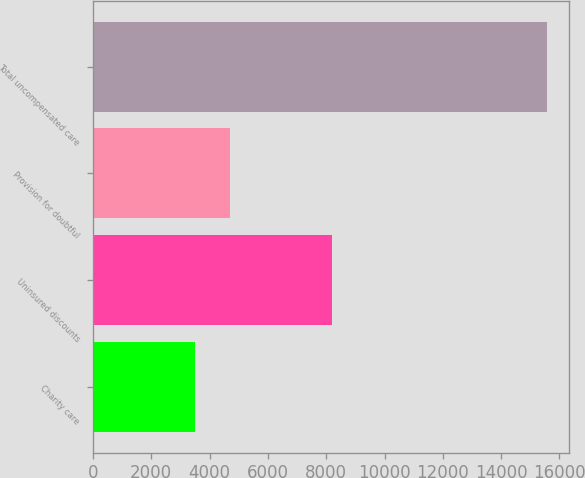Convert chart to OTSL. <chart><loc_0><loc_0><loc_500><loc_500><bar_chart><fcel>Charity care<fcel>Uninsured discounts<fcel>Provision for doubtful<fcel>Total uncompensated care<nl><fcel>3497<fcel>8210<fcel>4703.8<fcel>15565<nl></chart> 